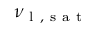<formula> <loc_0><loc_0><loc_500><loc_500>\nu _ { l , s a t }</formula> 